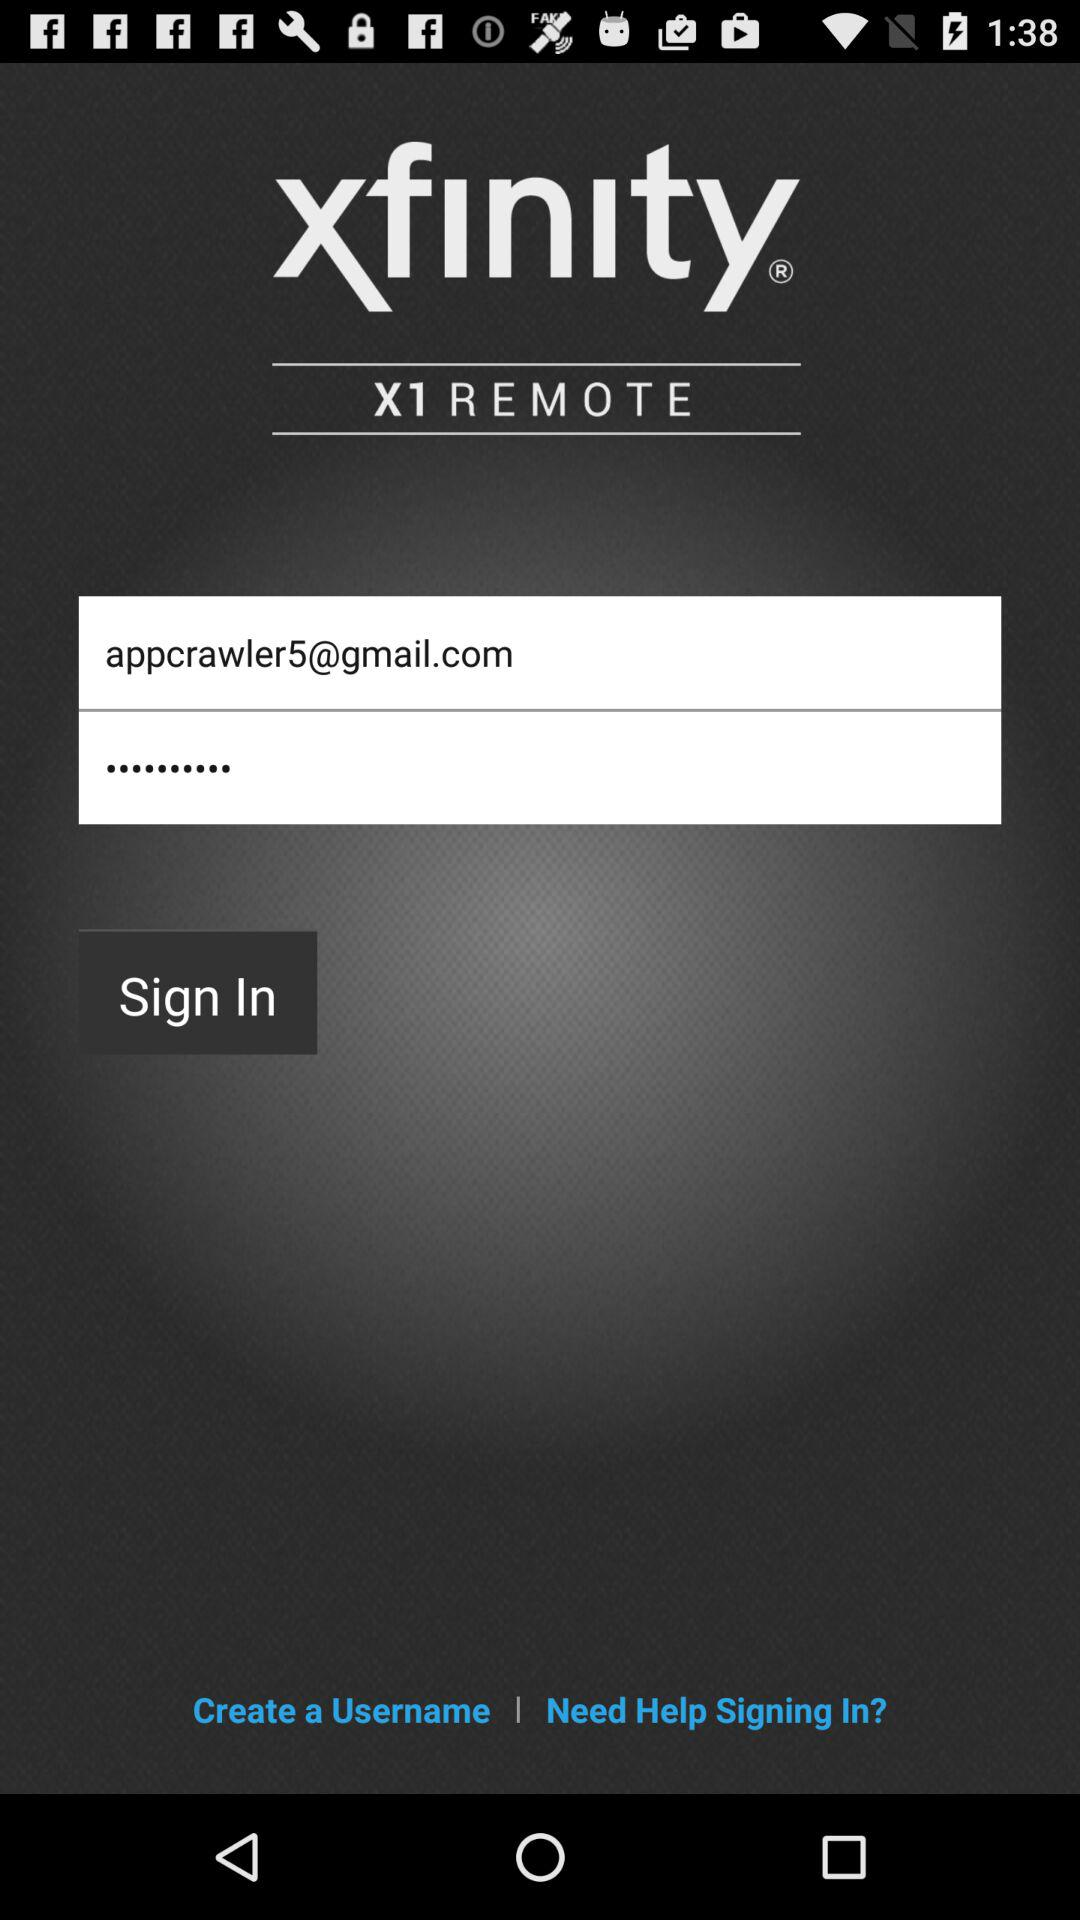What is the application name? The application name is "xfinity". 